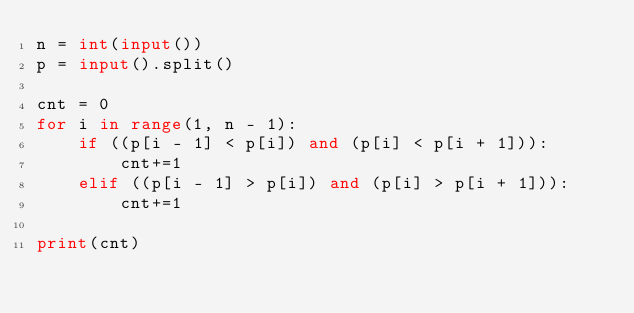<code> <loc_0><loc_0><loc_500><loc_500><_Python_>n = int(input())
p = input().split()

cnt = 0
for i in range(1, n - 1):
    if ((p[i - 1] < p[i]) and (p[i] < p[i + 1])):
        cnt+=1
    elif ((p[i - 1] > p[i]) and (p[i] > p[i + 1])):
        cnt+=1

print(cnt)
</code> 